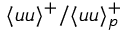<formula> <loc_0><loc_0><loc_500><loc_500>\langle u u \rangle ^ { + } / \langle u u \rangle _ { p } ^ { + }</formula> 